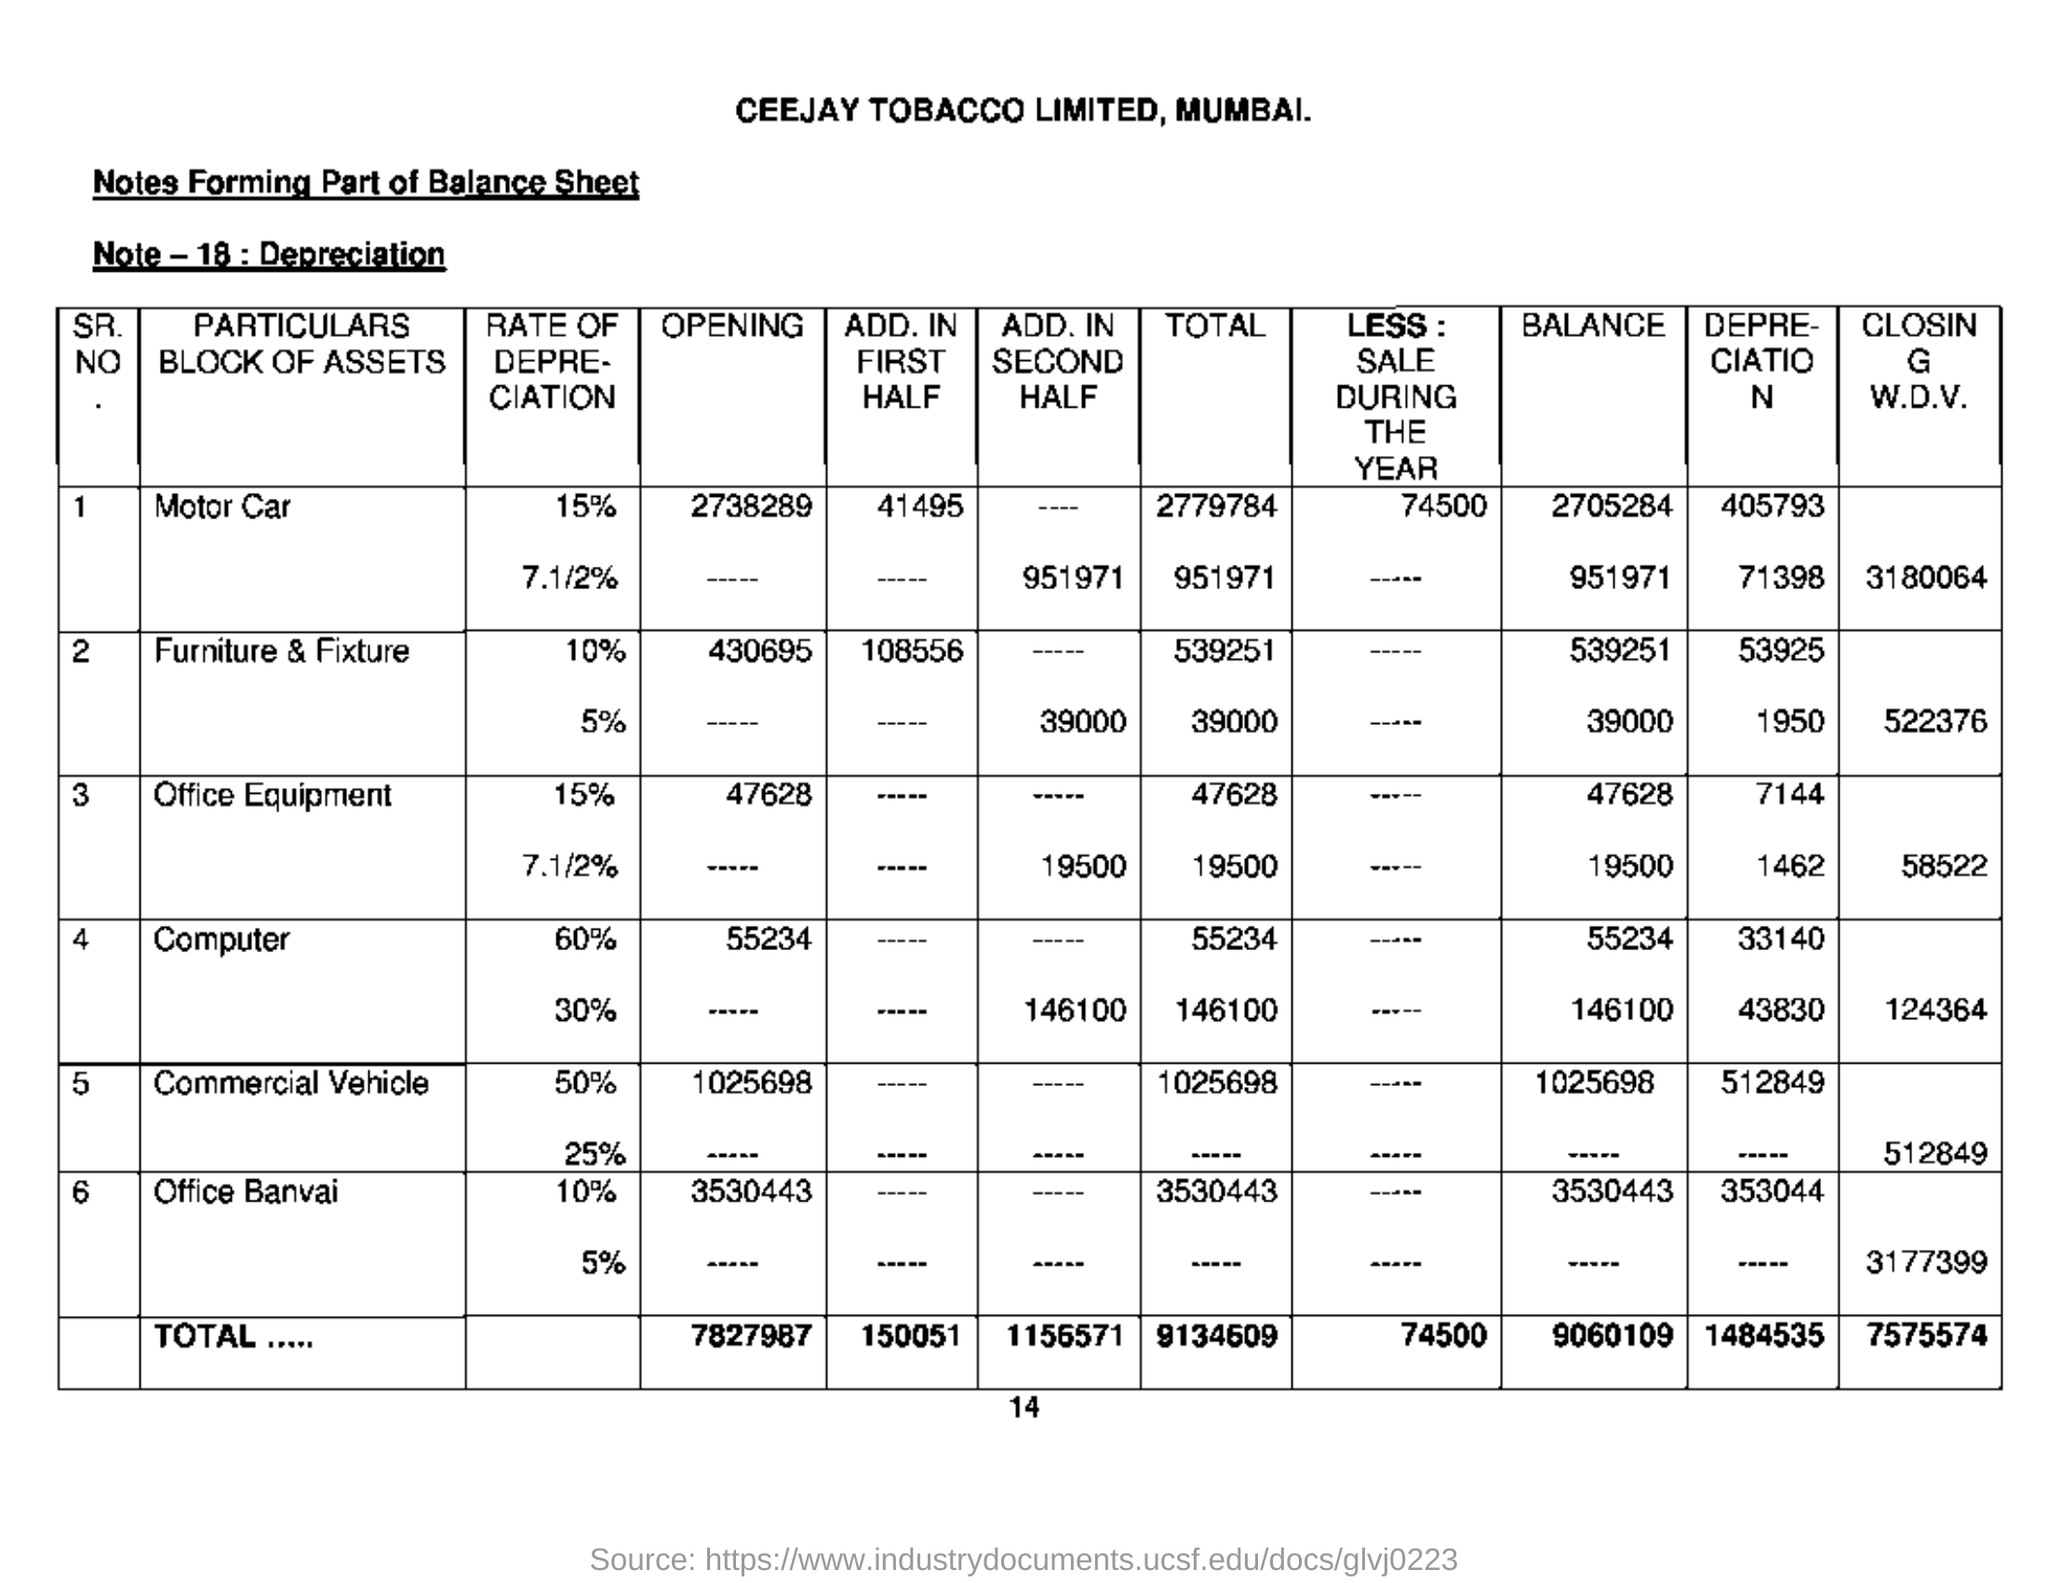Highlight a few significant elements in this photo. The note states that depreciation is discussed in Note-18. This is the balance sheet of CEEJAY TOBACCO LIMITED. 